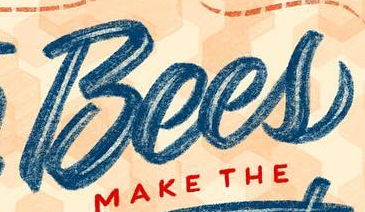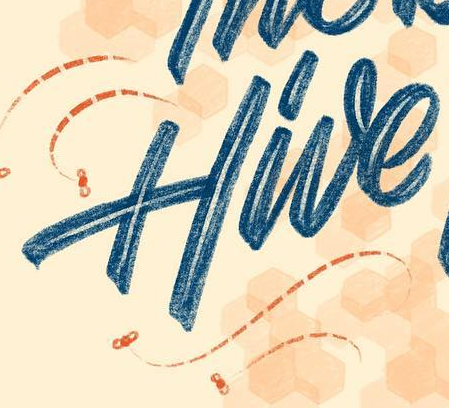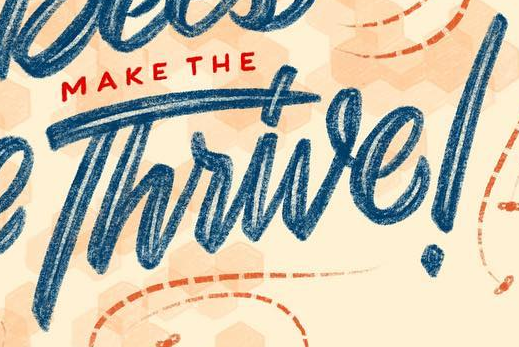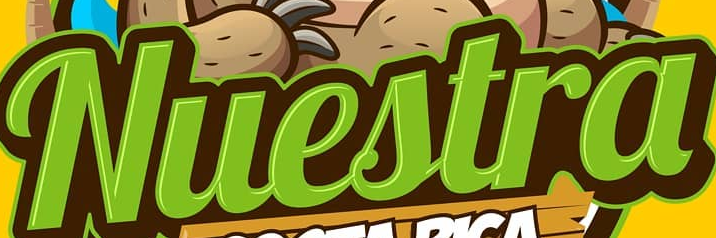What words are shown in these images in order, separated by a semicolon? Bees; Hive; Thrive!; Nuestra 